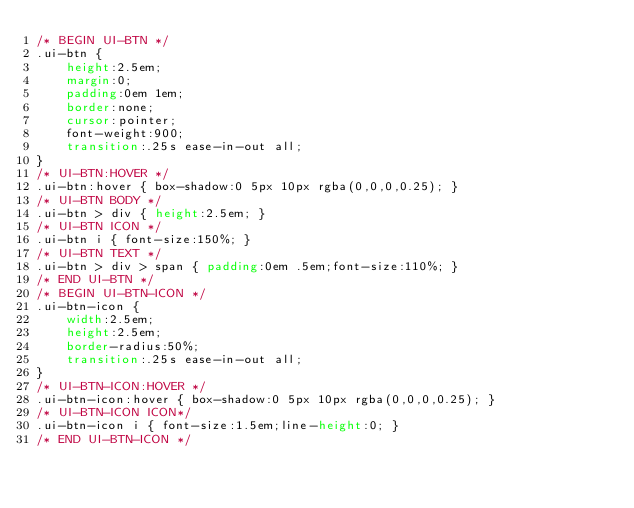Convert code to text. <code><loc_0><loc_0><loc_500><loc_500><_CSS_>/* BEGIN UI-BTN */
.ui-btn {
	height:2.5em;
	margin:0;
	padding:0em 1em;
	border:none;
	cursor:pointer;
	font-weight:900;
	transition:.25s ease-in-out all;
}
/* UI-BTN:HOVER */
.ui-btn:hover { box-shadow:0 5px 10px rgba(0,0,0,0.25); }
/* UI-BTN BODY */
.ui-btn > div { height:2.5em; }
/* UI-BTN ICON */
.ui-btn i { font-size:150%; }
/* UI-BTN TEXT */
.ui-btn > div > span { padding:0em .5em;font-size:110%; }
/* END UI-BTN */
/* BEGIN UI-BTN-ICON */
.ui-btn-icon {
	width:2.5em;
	height:2.5em;
	border-radius:50%;
	transition:.25s ease-in-out all;
}
/* UI-BTN-ICON:HOVER */
.ui-btn-icon:hover { box-shadow:0 5px 10px rgba(0,0,0,0.25); }
/* UI-BTN-ICON ICON*/
.ui-btn-icon i { font-size:1.5em;line-height:0; }
/* END UI-BTN-ICON */
</code> 